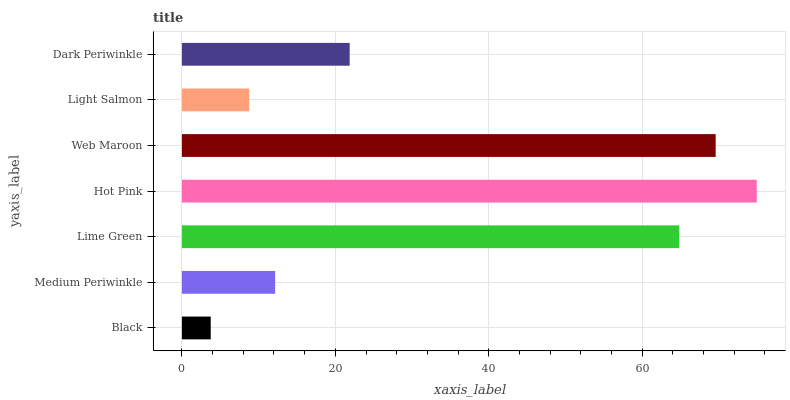Is Black the minimum?
Answer yes or no. Yes. Is Hot Pink the maximum?
Answer yes or no. Yes. Is Medium Periwinkle the minimum?
Answer yes or no. No. Is Medium Periwinkle the maximum?
Answer yes or no. No. Is Medium Periwinkle greater than Black?
Answer yes or no. Yes. Is Black less than Medium Periwinkle?
Answer yes or no. Yes. Is Black greater than Medium Periwinkle?
Answer yes or no. No. Is Medium Periwinkle less than Black?
Answer yes or no. No. Is Dark Periwinkle the high median?
Answer yes or no. Yes. Is Dark Periwinkle the low median?
Answer yes or no. Yes. Is Light Salmon the high median?
Answer yes or no. No. Is Lime Green the low median?
Answer yes or no. No. 